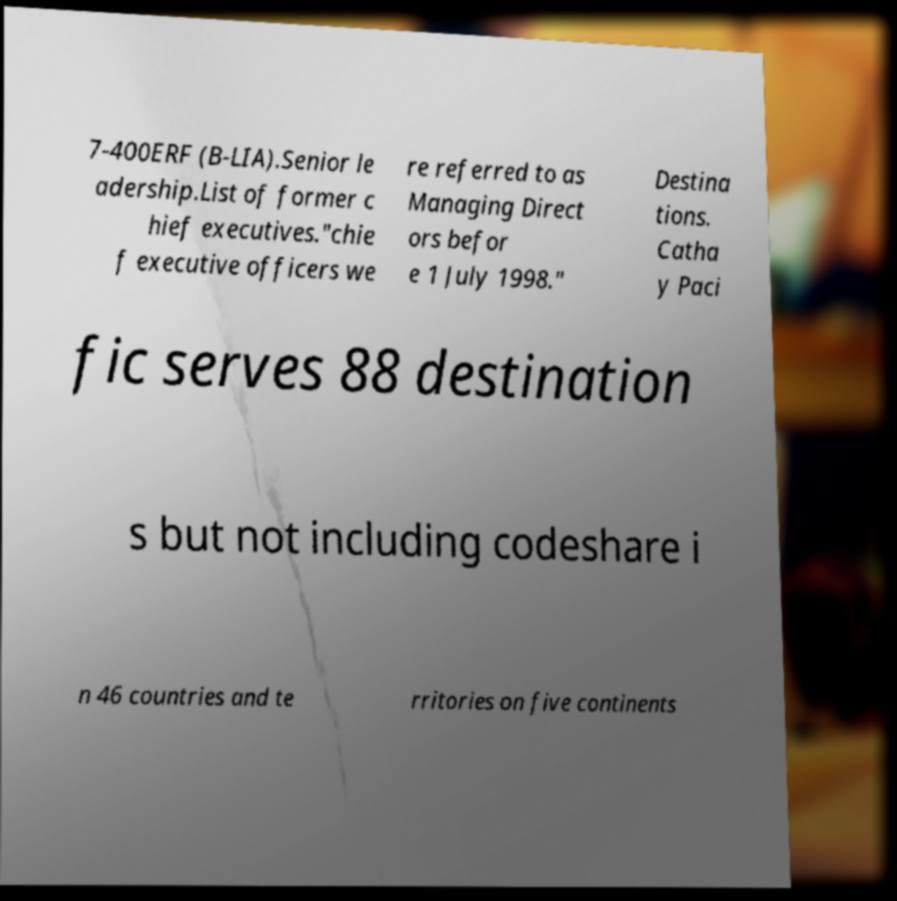Can you accurately transcribe the text from the provided image for me? 7-400ERF (B-LIA).Senior le adership.List of former c hief executives."chie f executive officers we re referred to as Managing Direct ors befor e 1 July 1998." Destina tions. Catha y Paci fic serves 88 destination s but not including codeshare i n 46 countries and te rritories on five continents 